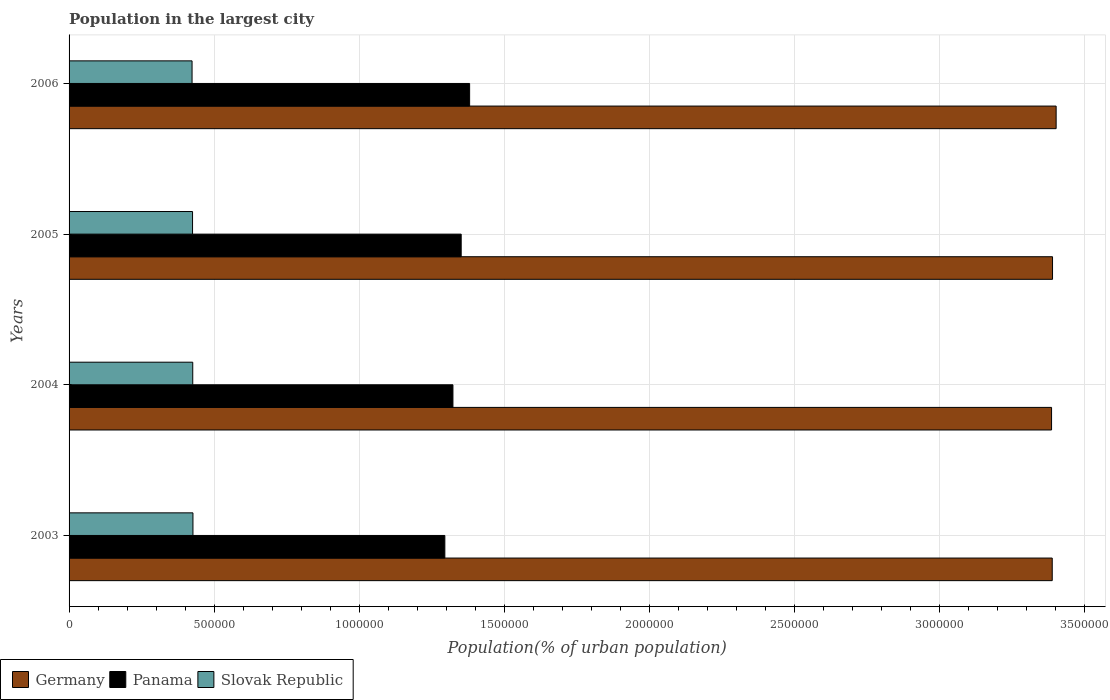How many different coloured bars are there?
Your response must be concise. 3. Are the number of bars per tick equal to the number of legend labels?
Keep it short and to the point. Yes. How many bars are there on the 2nd tick from the top?
Make the answer very short. 3. What is the label of the 2nd group of bars from the top?
Your answer should be compact. 2005. In how many cases, is the number of bars for a given year not equal to the number of legend labels?
Provide a short and direct response. 0. What is the population in the largest city in Panama in 2004?
Give a very brief answer. 1.32e+06. Across all years, what is the maximum population in the largest city in Germany?
Make the answer very short. 3.40e+06. Across all years, what is the minimum population in the largest city in Germany?
Your answer should be compact. 3.39e+06. In which year was the population in the largest city in Germany maximum?
Keep it short and to the point. 2006. In which year was the population in the largest city in Germany minimum?
Make the answer very short. 2004. What is the total population in the largest city in Slovak Republic in the graph?
Make the answer very short. 1.70e+06. What is the difference between the population in the largest city in Germany in 2003 and that in 2005?
Keep it short and to the point. -1040. What is the difference between the population in the largest city in Germany in 2004 and the population in the largest city in Panama in 2003?
Your response must be concise. 2.09e+06. What is the average population in the largest city in Germany per year?
Offer a terse response. 3.39e+06. In the year 2003, what is the difference between the population in the largest city in Germany and population in the largest city in Slovak Republic?
Provide a short and direct response. 2.96e+06. What is the ratio of the population in the largest city in Germany in 2003 to that in 2004?
Ensure brevity in your answer.  1. What is the difference between the highest and the second highest population in the largest city in Germany?
Your answer should be compact. 1.24e+04. What is the difference between the highest and the lowest population in the largest city in Germany?
Your answer should be very brief. 1.58e+04. What does the 1st bar from the bottom in 2003 represents?
Your answer should be very brief. Germany. How many bars are there?
Provide a short and direct response. 12. Are all the bars in the graph horizontal?
Offer a very short reply. Yes. Are the values on the major ticks of X-axis written in scientific E-notation?
Ensure brevity in your answer.  No. Does the graph contain any zero values?
Ensure brevity in your answer.  No. Does the graph contain grids?
Ensure brevity in your answer.  Yes. What is the title of the graph?
Make the answer very short. Population in the largest city. What is the label or title of the X-axis?
Offer a very short reply. Population(% of urban population). What is the label or title of the Y-axis?
Ensure brevity in your answer.  Years. What is the Population(% of urban population) of Germany in 2003?
Your answer should be compact. 3.39e+06. What is the Population(% of urban population) of Panama in 2003?
Keep it short and to the point. 1.30e+06. What is the Population(% of urban population) of Slovak Republic in 2003?
Provide a succinct answer. 4.27e+05. What is the Population(% of urban population) in Germany in 2004?
Your response must be concise. 3.39e+06. What is the Population(% of urban population) of Panama in 2004?
Give a very brief answer. 1.32e+06. What is the Population(% of urban population) of Slovak Republic in 2004?
Offer a very short reply. 4.27e+05. What is the Population(% of urban population) of Germany in 2005?
Your response must be concise. 3.39e+06. What is the Population(% of urban population) in Panama in 2005?
Provide a succinct answer. 1.35e+06. What is the Population(% of urban population) in Slovak Republic in 2005?
Keep it short and to the point. 4.26e+05. What is the Population(% of urban population) in Germany in 2006?
Provide a succinct answer. 3.40e+06. What is the Population(% of urban population) of Panama in 2006?
Your answer should be compact. 1.38e+06. What is the Population(% of urban population) of Slovak Republic in 2006?
Offer a very short reply. 4.24e+05. Across all years, what is the maximum Population(% of urban population) in Germany?
Your response must be concise. 3.40e+06. Across all years, what is the maximum Population(% of urban population) of Panama?
Make the answer very short. 1.38e+06. Across all years, what is the maximum Population(% of urban population) in Slovak Republic?
Offer a very short reply. 4.27e+05. Across all years, what is the minimum Population(% of urban population) in Germany?
Provide a short and direct response. 3.39e+06. Across all years, what is the minimum Population(% of urban population) in Panama?
Your answer should be compact. 1.30e+06. Across all years, what is the minimum Population(% of urban population) of Slovak Republic?
Offer a terse response. 4.24e+05. What is the total Population(% of urban population) in Germany in the graph?
Your answer should be compact. 1.36e+07. What is the total Population(% of urban population) in Panama in the graph?
Your response must be concise. 5.35e+06. What is the total Population(% of urban population) of Slovak Republic in the graph?
Make the answer very short. 1.70e+06. What is the difference between the Population(% of urban population) of Germany in 2003 and that in 2004?
Your answer should be very brief. 2304. What is the difference between the Population(% of urban population) of Panama in 2003 and that in 2004?
Your response must be concise. -2.79e+04. What is the difference between the Population(% of urban population) of Slovak Republic in 2003 and that in 2004?
Keep it short and to the point. 699. What is the difference between the Population(% of urban population) of Germany in 2003 and that in 2005?
Your answer should be very brief. -1040. What is the difference between the Population(% of urban population) of Panama in 2003 and that in 2005?
Your response must be concise. -5.64e+04. What is the difference between the Population(% of urban population) in Slovak Republic in 2003 and that in 2005?
Offer a very short reply. 1395. What is the difference between the Population(% of urban population) in Germany in 2003 and that in 2006?
Make the answer very short. -1.35e+04. What is the difference between the Population(% of urban population) in Panama in 2003 and that in 2006?
Keep it short and to the point. -8.55e+04. What is the difference between the Population(% of urban population) in Slovak Republic in 2003 and that in 2006?
Your response must be concise. 3082. What is the difference between the Population(% of urban population) in Germany in 2004 and that in 2005?
Your response must be concise. -3344. What is the difference between the Population(% of urban population) in Panama in 2004 and that in 2005?
Give a very brief answer. -2.85e+04. What is the difference between the Population(% of urban population) of Slovak Republic in 2004 and that in 2005?
Your answer should be very brief. 696. What is the difference between the Population(% of urban population) in Germany in 2004 and that in 2006?
Provide a short and direct response. -1.58e+04. What is the difference between the Population(% of urban population) of Panama in 2004 and that in 2006?
Ensure brevity in your answer.  -5.76e+04. What is the difference between the Population(% of urban population) of Slovak Republic in 2004 and that in 2006?
Your answer should be very brief. 2383. What is the difference between the Population(% of urban population) of Germany in 2005 and that in 2006?
Give a very brief answer. -1.24e+04. What is the difference between the Population(% of urban population) of Panama in 2005 and that in 2006?
Ensure brevity in your answer.  -2.91e+04. What is the difference between the Population(% of urban population) in Slovak Republic in 2005 and that in 2006?
Keep it short and to the point. 1687. What is the difference between the Population(% of urban population) in Germany in 2003 and the Population(% of urban population) in Panama in 2004?
Offer a terse response. 2.07e+06. What is the difference between the Population(% of urban population) of Germany in 2003 and the Population(% of urban population) of Slovak Republic in 2004?
Provide a succinct answer. 2.96e+06. What is the difference between the Population(% of urban population) of Panama in 2003 and the Population(% of urban population) of Slovak Republic in 2004?
Provide a succinct answer. 8.69e+05. What is the difference between the Population(% of urban population) in Germany in 2003 and the Population(% of urban population) in Panama in 2005?
Ensure brevity in your answer.  2.04e+06. What is the difference between the Population(% of urban population) in Germany in 2003 and the Population(% of urban population) in Slovak Republic in 2005?
Your answer should be compact. 2.96e+06. What is the difference between the Population(% of urban population) of Panama in 2003 and the Population(% of urban population) of Slovak Republic in 2005?
Offer a terse response. 8.70e+05. What is the difference between the Population(% of urban population) of Germany in 2003 and the Population(% of urban population) of Panama in 2006?
Provide a succinct answer. 2.01e+06. What is the difference between the Population(% of urban population) of Germany in 2003 and the Population(% of urban population) of Slovak Republic in 2006?
Make the answer very short. 2.97e+06. What is the difference between the Population(% of urban population) of Panama in 2003 and the Population(% of urban population) of Slovak Republic in 2006?
Offer a very short reply. 8.72e+05. What is the difference between the Population(% of urban population) of Germany in 2004 and the Population(% of urban population) of Panama in 2005?
Make the answer very short. 2.04e+06. What is the difference between the Population(% of urban population) of Germany in 2004 and the Population(% of urban population) of Slovak Republic in 2005?
Keep it short and to the point. 2.96e+06. What is the difference between the Population(% of urban population) in Panama in 2004 and the Population(% of urban population) in Slovak Republic in 2005?
Offer a terse response. 8.98e+05. What is the difference between the Population(% of urban population) of Germany in 2004 and the Population(% of urban population) of Panama in 2006?
Provide a short and direct response. 2.01e+06. What is the difference between the Population(% of urban population) of Germany in 2004 and the Population(% of urban population) of Slovak Republic in 2006?
Make the answer very short. 2.96e+06. What is the difference between the Population(% of urban population) in Panama in 2004 and the Population(% of urban population) in Slovak Republic in 2006?
Provide a short and direct response. 9.00e+05. What is the difference between the Population(% of urban population) of Germany in 2005 and the Population(% of urban population) of Panama in 2006?
Give a very brief answer. 2.01e+06. What is the difference between the Population(% of urban population) of Germany in 2005 and the Population(% of urban population) of Slovak Republic in 2006?
Give a very brief answer. 2.97e+06. What is the difference between the Population(% of urban population) of Panama in 2005 and the Population(% of urban population) of Slovak Republic in 2006?
Your response must be concise. 9.28e+05. What is the average Population(% of urban population) of Germany per year?
Provide a succinct answer. 3.39e+06. What is the average Population(% of urban population) in Panama per year?
Ensure brevity in your answer.  1.34e+06. What is the average Population(% of urban population) of Slovak Republic per year?
Your answer should be compact. 4.26e+05. In the year 2003, what is the difference between the Population(% of urban population) in Germany and Population(% of urban population) in Panama?
Your response must be concise. 2.09e+06. In the year 2003, what is the difference between the Population(% of urban population) of Germany and Population(% of urban population) of Slovak Republic?
Ensure brevity in your answer.  2.96e+06. In the year 2003, what is the difference between the Population(% of urban population) in Panama and Population(% of urban population) in Slovak Republic?
Your answer should be very brief. 8.69e+05. In the year 2004, what is the difference between the Population(% of urban population) in Germany and Population(% of urban population) in Panama?
Offer a terse response. 2.06e+06. In the year 2004, what is the difference between the Population(% of urban population) in Germany and Population(% of urban population) in Slovak Republic?
Your answer should be very brief. 2.96e+06. In the year 2004, what is the difference between the Population(% of urban population) of Panama and Population(% of urban population) of Slovak Republic?
Ensure brevity in your answer.  8.97e+05. In the year 2005, what is the difference between the Population(% of urban population) in Germany and Population(% of urban population) in Panama?
Give a very brief answer. 2.04e+06. In the year 2005, what is the difference between the Population(% of urban population) of Germany and Population(% of urban population) of Slovak Republic?
Your answer should be compact. 2.97e+06. In the year 2005, what is the difference between the Population(% of urban population) of Panama and Population(% of urban population) of Slovak Republic?
Your answer should be very brief. 9.26e+05. In the year 2006, what is the difference between the Population(% of urban population) of Germany and Population(% of urban population) of Panama?
Keep it short and to the point. 2.02e+06. In the year 2006, what is the difference between the Population(% of urban population) in Germany and Population(% of urban population) in Slovak Republic?
Your answer should be compact. 2.98e+06. In the year 2006, what is the difference between the Population(% of urban population) of Panama and Population(% of urban population) of Slovak Republic?
Offer a very short reply. 9.57e+05. What is the ratio of the Population(% of urban population) of Germany in 2003 to that in 2004?
Offer a terse response. 1. What is the ratio of the Population(% of urban population) in Panama in 2003 to that in 2004?
Your response must be concise. 0.98. What is the ratio of the Population(% of urban population) in Germany in 2003 to that in 2006?
Give a very brief answer. 1. What is the ratio of the Population(% of urban population) in Panama in 2003 to that in 2006?
Your answer should be very brief. 0.94. What is the ratio of the Population(% of urban population) in Slovak Republic in 2003 to that in 2006?
Give a very brief answer. 1.01. What is the ratio of the Population(% of urban population) in Germany in 2004 to that in 2005?
Offer a terse response. 1. What is the ratio of the Population(% of urban population) of Slovak Republic in 2004 to that in 2005?
Ensure brevity in your answer.  1. What is the ratio of the Population(% of urban population) in Germany in 2004 to that in 2006?
Give a very brief answer. 1. What is the ratio of the Population(% of urban population) in Slovak Republic in 2004 to that in 2006?
Your answer should be compact. 1.01. What is the ratio of the Population(% of urban population) of Panama in 2005 to that in 2006?
Your answer should be compact. 0.98. What is the difference between the highest and the second highest Population(% of urban population) in Germany?
Give a very brief answer. 1.24e+04. What is the difference between the highest and the second highest Population(% of urban population) of Panama?
Your answer should be very brief. 2.91e+04. What is the difference between the highest and the second highest Population(% of urban population) in Slovak Republic?
Your answer should be compact. 699. What is the difference between the highest and the lowest Population(% of urban population) of Germany?
Ensure brevity in your answer.  1.58e+04. What is the difference between the highest and the lowest Population(% of urban population) of Panama?
Provide a succinct answer. 8.55e+04. What is the difference between the highest and the lowest Population(% of urban population) of Slovak Republic?
Provide a short and direct response. 3082. 